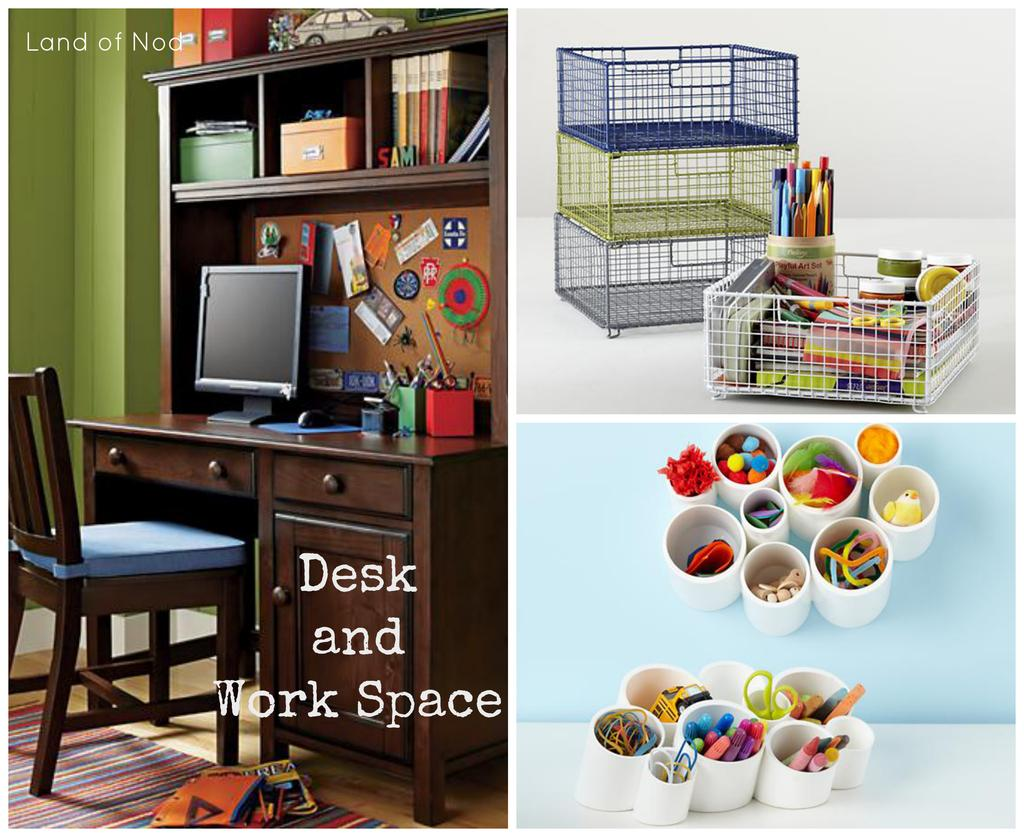<image>
Provide a brief description of the given image. A variety of baskets and cups for storage usable at the desk and work space. 